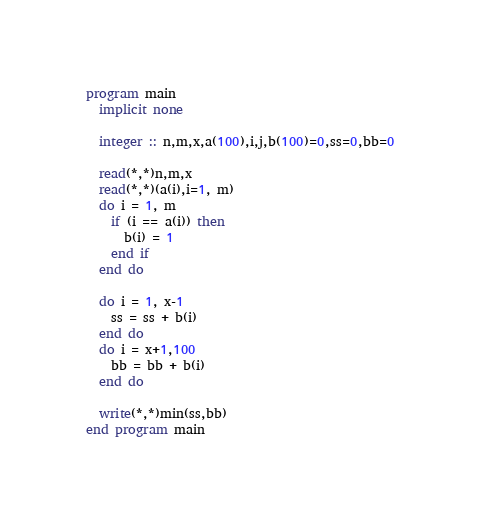<code> <loc_0><loc_0><loc_500><loc_500><_FORTRAN_>program main
  implicit none
  
  integer :: n,m,x,a(100),i,j,b(100)=0,ss=0,bb=0
  
  read(*,*)n,m,x
  read(*,*)(a(i),i=1, m)
  do i = 1, m
    if (i == a(i)) then
      b(i) = 1
    end if
  end do
  
  do i = 1, x-1
    ss = ss + b(i)
  end do
  do i = x+1,100
    bb = bb + b(i)
  end do
  
  write(*,*)min(ss,bb)
end program main</code> 